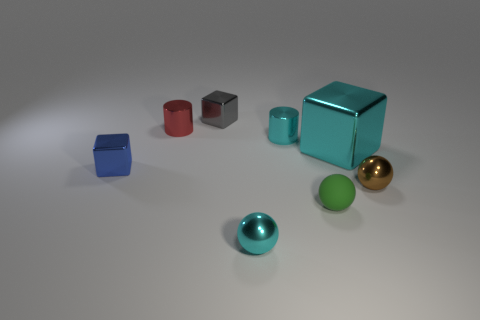How many things are either large gray rubber objects or metal balls that are behind the green sphere?
Ensure brevity in your answer.  1. What number of tiny metallic balls are on the right side of the cyan metal object in front of the small metal sphere behind the rubber object?
Make the answer very short. 1. There is a small sphere that is the same color as the big metal block; what material is it?
Ensure brevity in your answer.  Metal. What number of cyan metallic objects are there?
Your answer should be very brief. 3. There is a metallic object in front of the green matte sphere; is its size the same as the tiny rubber ball?
Ensure brevity in your answer.  Yes. What number of matte objects are either tiny red cylinders or cyan balls?
Offer a very short reply. 0. How many shiny things are right of the small metallic object that is in front of the brown metallic sphere?
Your answer should be compact. 3. What shape is the cyan metallic thing that is on the left side of the large cyan cube and behind the green rubber sphere?
Provide a succinct answer. Cylinder. The object behind the cylinder that is left of the cyan thing in front of the tiny blue shiny object is made of what material?
Offer a very short reply. Metal. What is the size of the sphere that is the same color as the big shiny thing?
Provide a succinct answer. Small. 